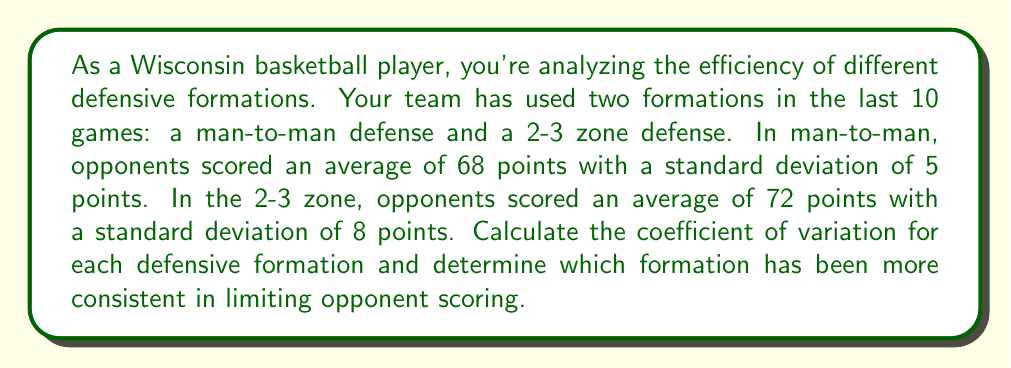Provide a solution to this math problem. To solve this problem, we need to calculate the coefficient of variation (CV) for each defensive formation. The CV is a standardized measure of dispersion that allows us to compare the variability of data sets with different means.

The formula for the coefficient of variation is:

$$ CV = \frac{\text{Standard Deviation}}{\text{Mean}} \times 100\% $$

For the man-to-man defense:
Mean ($\mu_1$) = 68 points
Standard Deviation ($\sigma_1$) = 5 points

$$ CV_{\text{man-to-man}} = \frac{5}{68} \times 100\% = 7.35\% $$

For the 2-3 zone defense:
Mean ($\mu_2$) = 72 points
Standard Deviation ($\sigma_2$) = 8 points

$$ CV_{\text{2-3 zone}} = \frac{8}{72} \times 100\% = 11.11\% $$

The lower the coefficient of variation, the more consistent the defensive formation is in limiting opponent scoring. In this case, the man-to-man defense has a lower CV (7.35%) compared to the 2-3 zone defense (11.11%).

Therefore, the man-to-man defense has been more consistent in limiting opponent scoring.
Answer: The man-to-man defense has been more consistent, with a coefficient of variation of 7.35% compared to 11.11% for the 2-3 zone defense. 